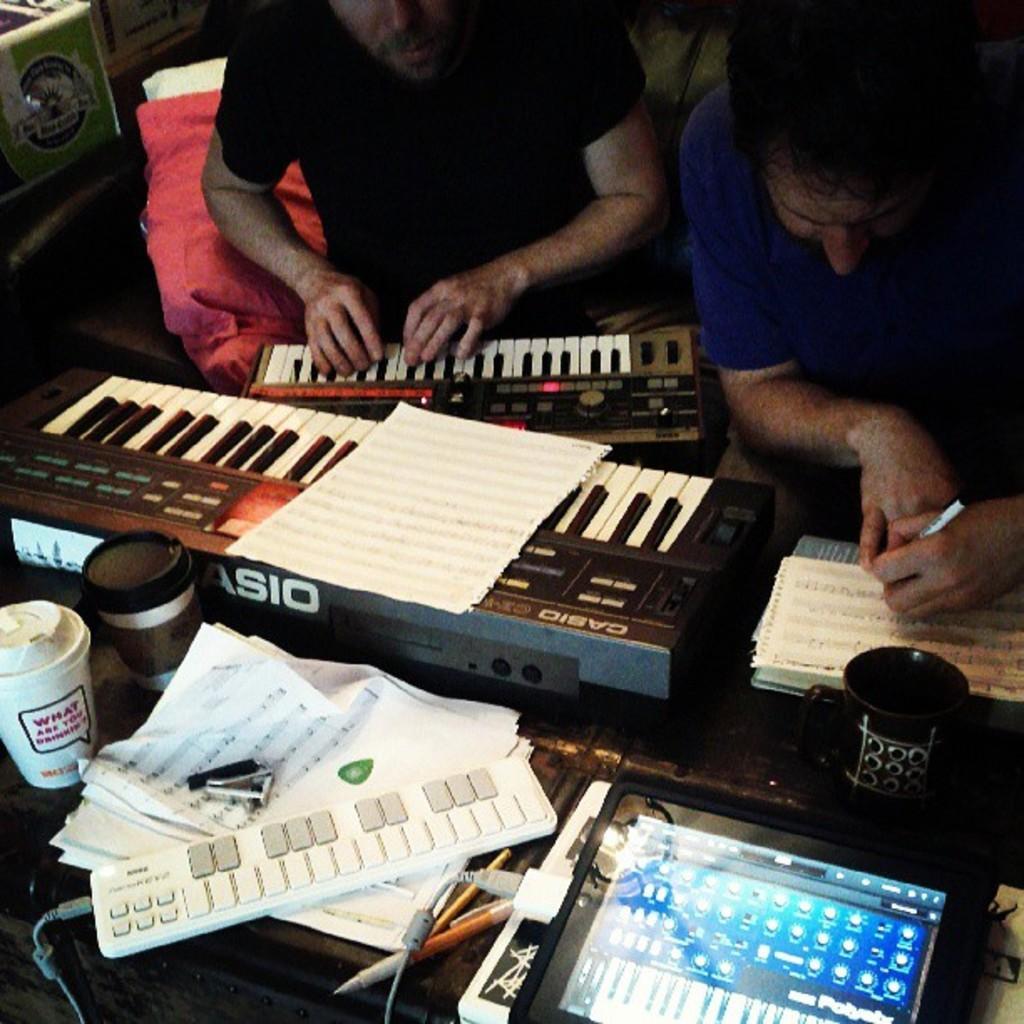Can you describe this image briefly? In this picture there are two person sitting on a couch. Right person holding a pen and writing something on a paper, left person playing a piano. Here it's a cup. On the table, there is a tablet which is connected a wire and some white objects. This object having a buttons. There is a book. 